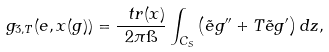Convert formula to latex. <formula><loc_0><loc_0><loc_500><loc_500>\ g _ { 3 , T } ( e , x ( g ) ) = \frac { \ t r ( x ) } { 2 \pi \i } \int _ { C _ { S } } \left ( \tilde { e } g ^ { \prime \prime } + T \tilde { e } g ^ { \prime } \right ) d z ,</formula> 